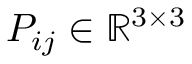<formula> <loc_0><loc_0><loc_500><loc_500>P _ { i j } \in \mathbb { R } ^ { 3 \times 3 }</formula> 